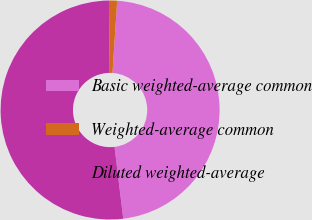Convert chart. <chart><loc_0><loc_0><loc_500><loc_500><pie_chart><fcel>Basic weighted-average common<fcel>Weighted-average common<fcel>Diluted weighted-average<nl><fcel>47.05%<fcel>1.2%<fcel>51.75%<nl></chart> 